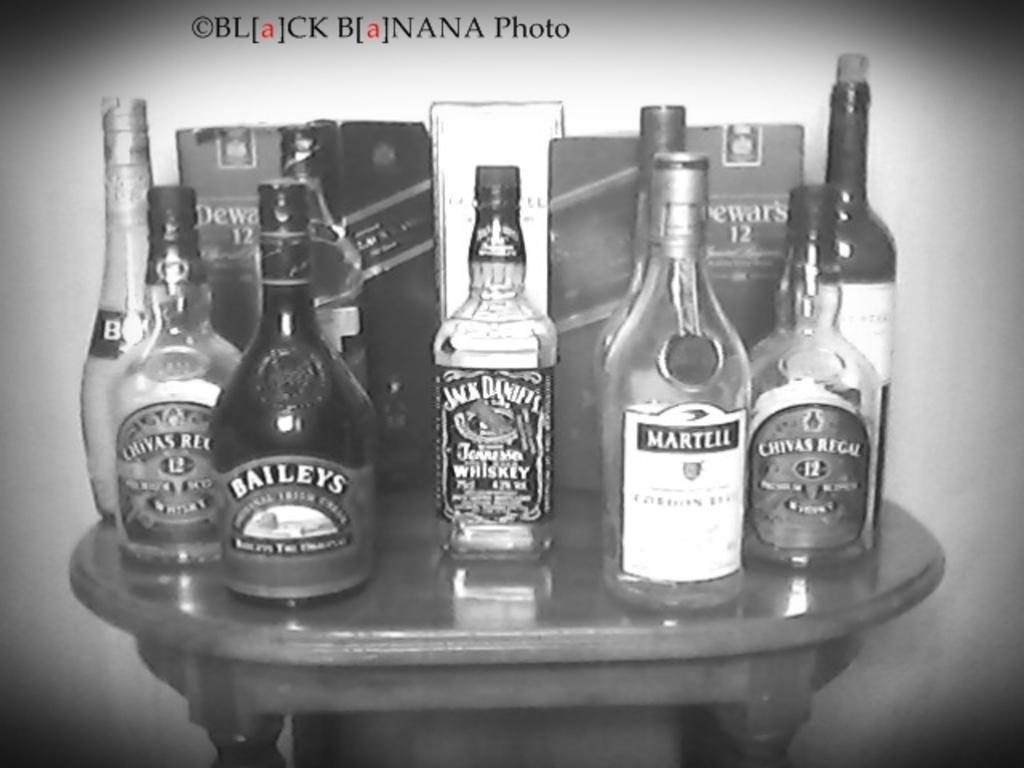Describe this image in one or two sentences. This is the black and white image. There are so many bottles in this image. All the bottles are placed on the table. 